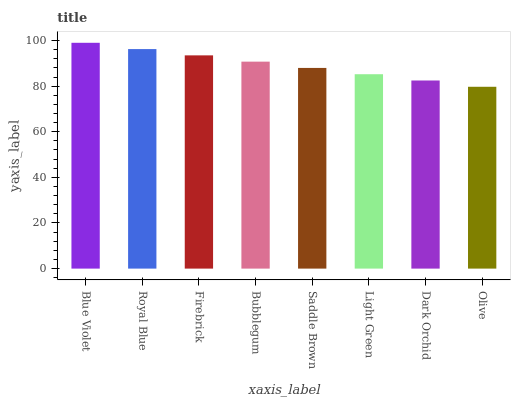Is Olive the minimum?
Answer yes or no. Yes. Is Blue Violet the maximum?
Answer yes or no. Yes. Is Royal Blue the minimum?
Answer yes or no. No. Is Royal Blue the maximum?
Answer yes or no. No. Is Blue Violet greater than Royal Blue?
Answer yes or no. Yes. Is Royal Blue less than Blue Violet?
Answer yes or no. Yes. Is Royal Blue greater than Blue Violet?
Answer yes or no. No. Is Blue Violet less than Royal Blue?
Answer yes or no. No. Is Bubblegum the high median?
Answer yes or no. Yes. Is Saddle Brown the low median?
Answer yes or no. Yes. Is Dark Orchid the high median?
Answer yes or no. No. Is Light Green the low median?
Answer yes or no. No. 